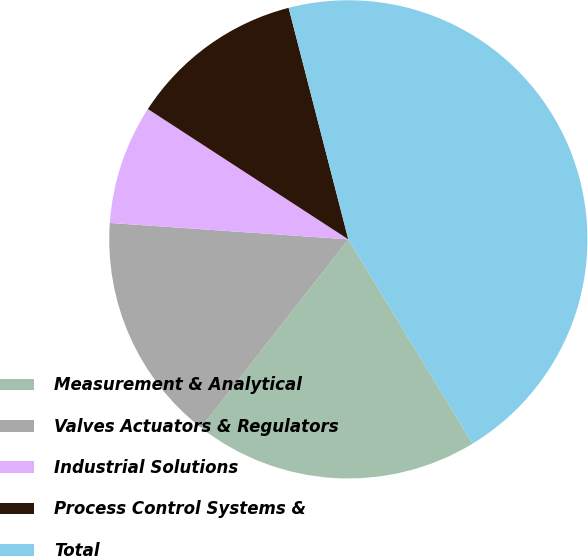Convert chart. <chart><loc_0><loc_0><loc_500><loc_500><pie_chart><fcel>Measurement & Analytical<fcel>Valves Actuators & Regulators<fcel>Industrial Solutions<fcel>Process Control Systems &<fcel>Total<nl><fcel>19.26%<fcel>15.53%<fcel>8.08%<fcel>11.81%<fcel>45.32%<nl></chart> 